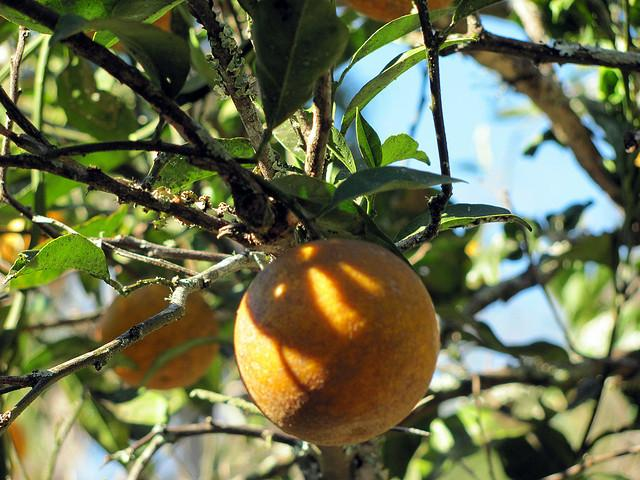Which acid is present in orange? Please explain your reasoning. citric acid. The orange has citric. 